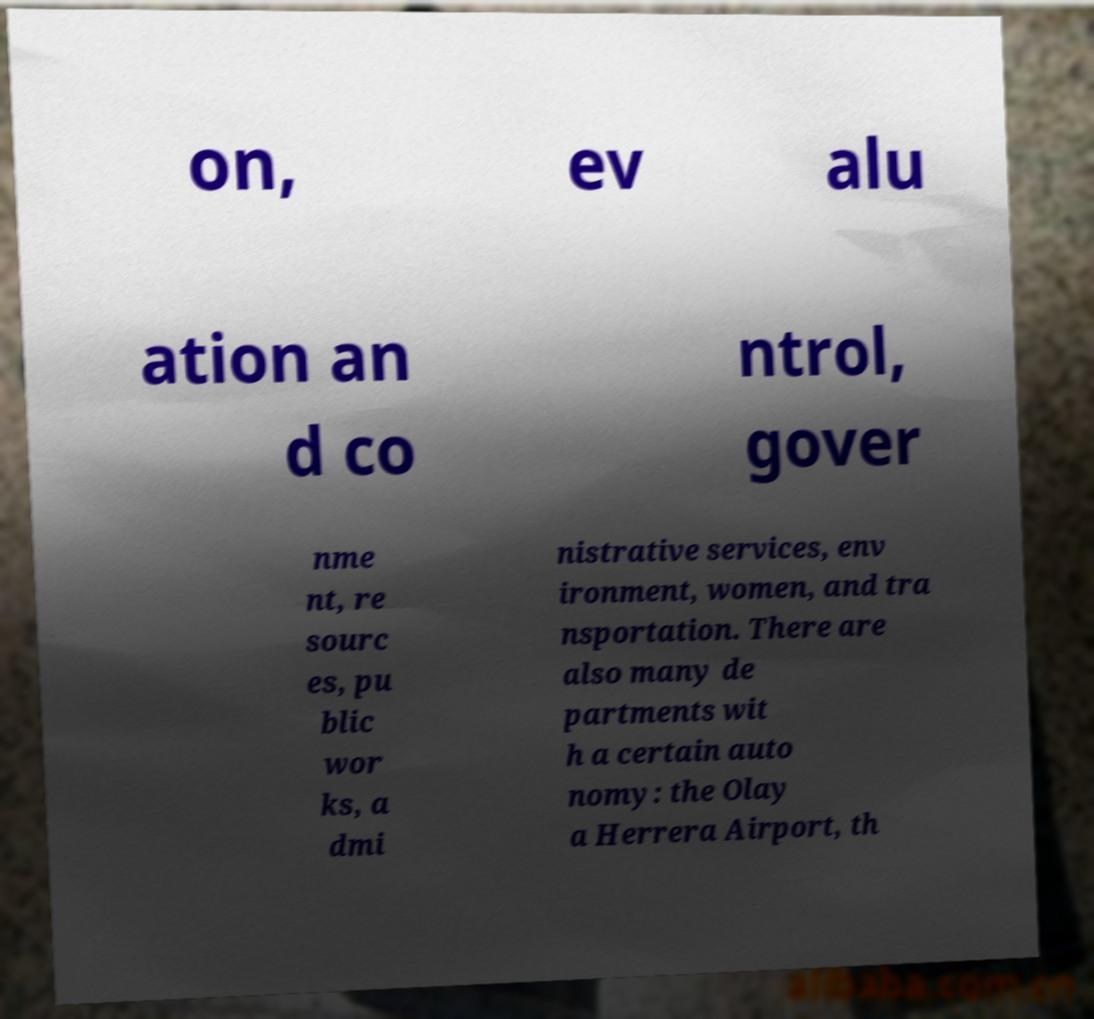For documentation purposes, I need the text within this image transcribed. Could you provide that? on, ev alu ation an d co ntrol, gover nme nt, re sourc es, pu blic wor ks, a dmi nistrative services, env ironment, women, and tra nsportation. There are also many de partments wit h a certain auto nomy: the Olay a Herrera Airport, th 